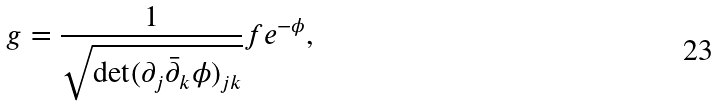<formula> <loc_0><loc_0><loc_500><loc_500>g = \frac { 1 } { \sqrt { \det ( \partial _ { j } \bar { \partial } _ { k } \phi ) _ { j k } } } f e ^ { - \phi } ,</formula> 